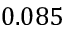Convert formula to latex. <formula><loc_0><loc_0><loc_500><loc_500>0 . 0 8 5</formula> 